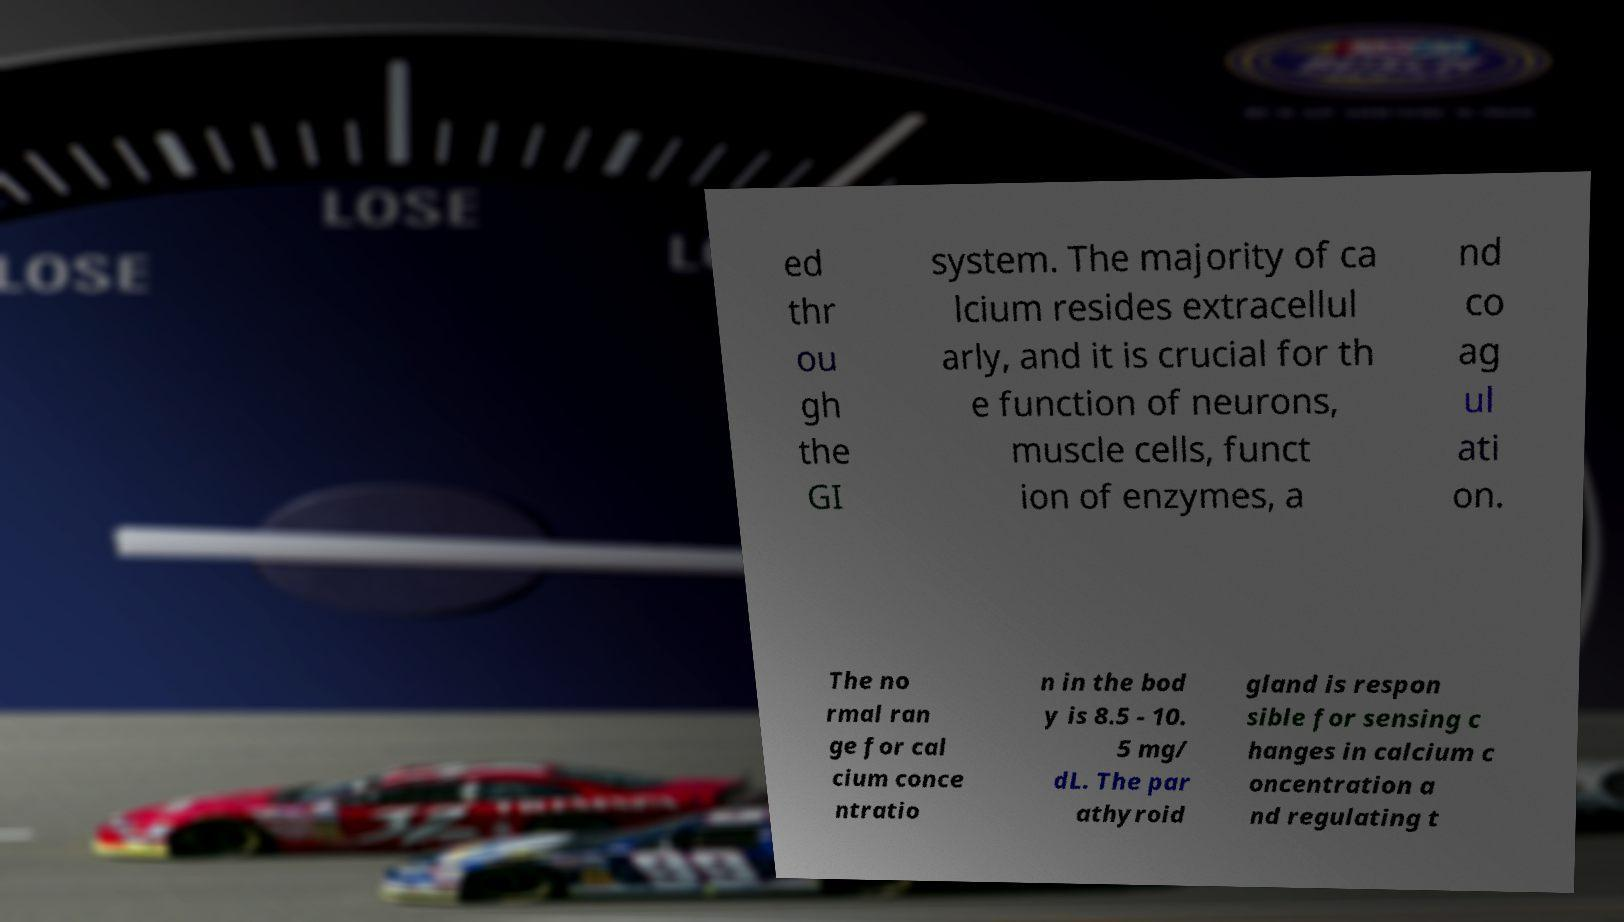Could you extract and type out the text from this image? ed thr ou gh the GI system. The majority of ca lcium resides extracellul arly, and it is crucial for th e function of neurons, muscle cells, funct ion of enzymes, a nd co ag ul ati on. The no rmal ran ge for cal cium conce ntratio n in the bod y is 8.5 - 10. 5 mg/ dL. The par athyroid gland is respon sible for sensing c hanges in calcium c oncentration a nd regulating t 